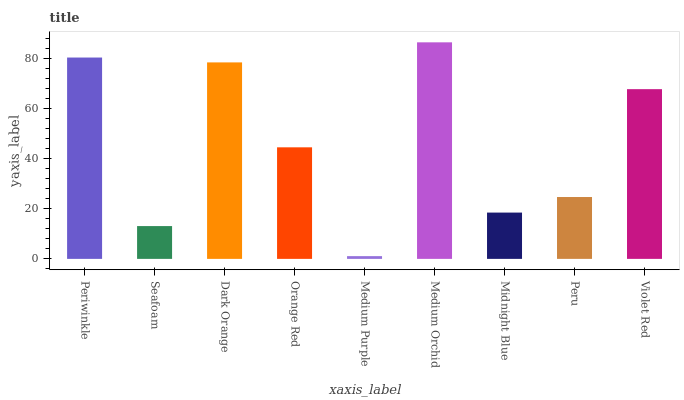Is Medium Purple the minimum?
Answer yes or no. Yes. Is Medium Orchid the maximum?
Answer yes or no. Yes. Is Seafoam the minimum?
Answer yes or no. No. Is Seafoam the maximum?
Answer yes or no. No. Is Periwinkle greater than Seafoam?
Answer yes or no. Yes. Is Seafoam less than Periwinkle?
Answer yes or no. Yes. Is Seafoam greater than Periwinkle?
Answer yes or no. No. Is Periwinkle less than Seafoam?
Answer yes or no. No. Is Orange Red the high median?
Answer yes or no. Yes. Is Orange Red the low median?
Answer yes or no. Yes. Is Peru the high median?
Answer yes or no. No. Is Periwinkle the low median?
Answer yes or no. No. 